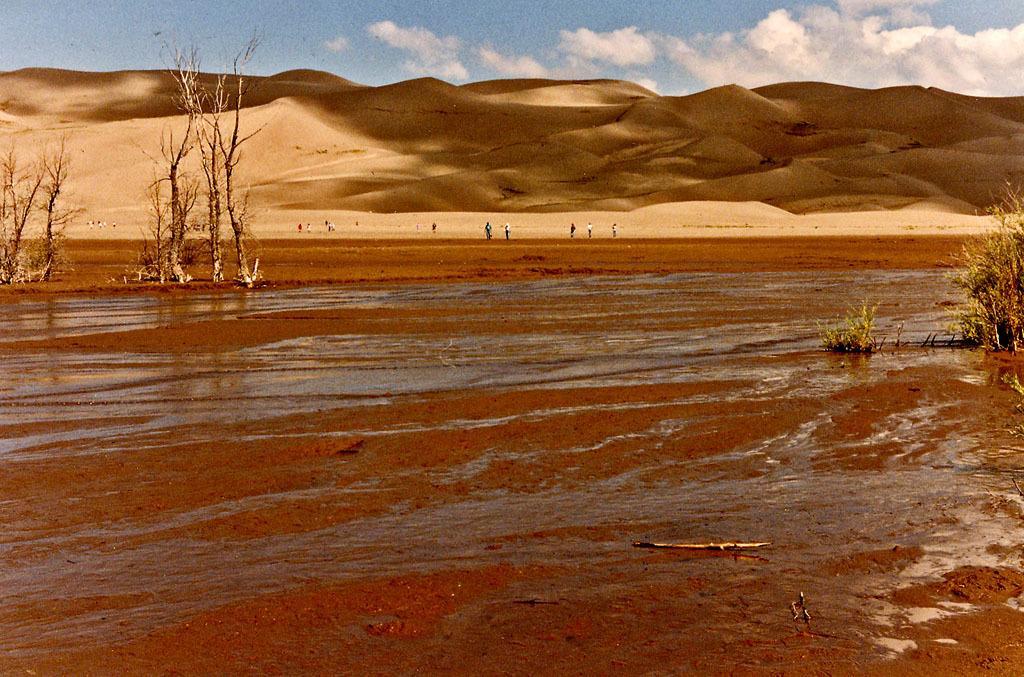In one or two sentences, can you explain what this image depicts? In this picture we can see water, trees and some people standing, mountains and in the background we can see the sky with clouds. 